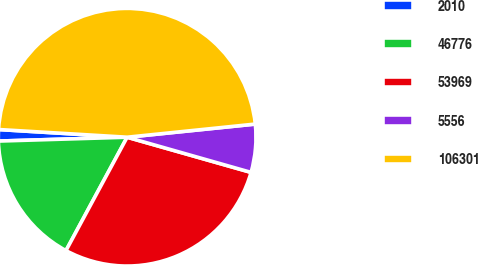Convert chart. <chart><loc_0><loc_0><loc_500><loc_500><pie_chart><fcel>2010<fcel>46776<fcel>53969<fcel>5556<fcel>106301<nl><fcel>1.43%<fcel>16.65%<fcel>28.47%<fcel>6.03%<fcel>47.42%<nl></chart> 